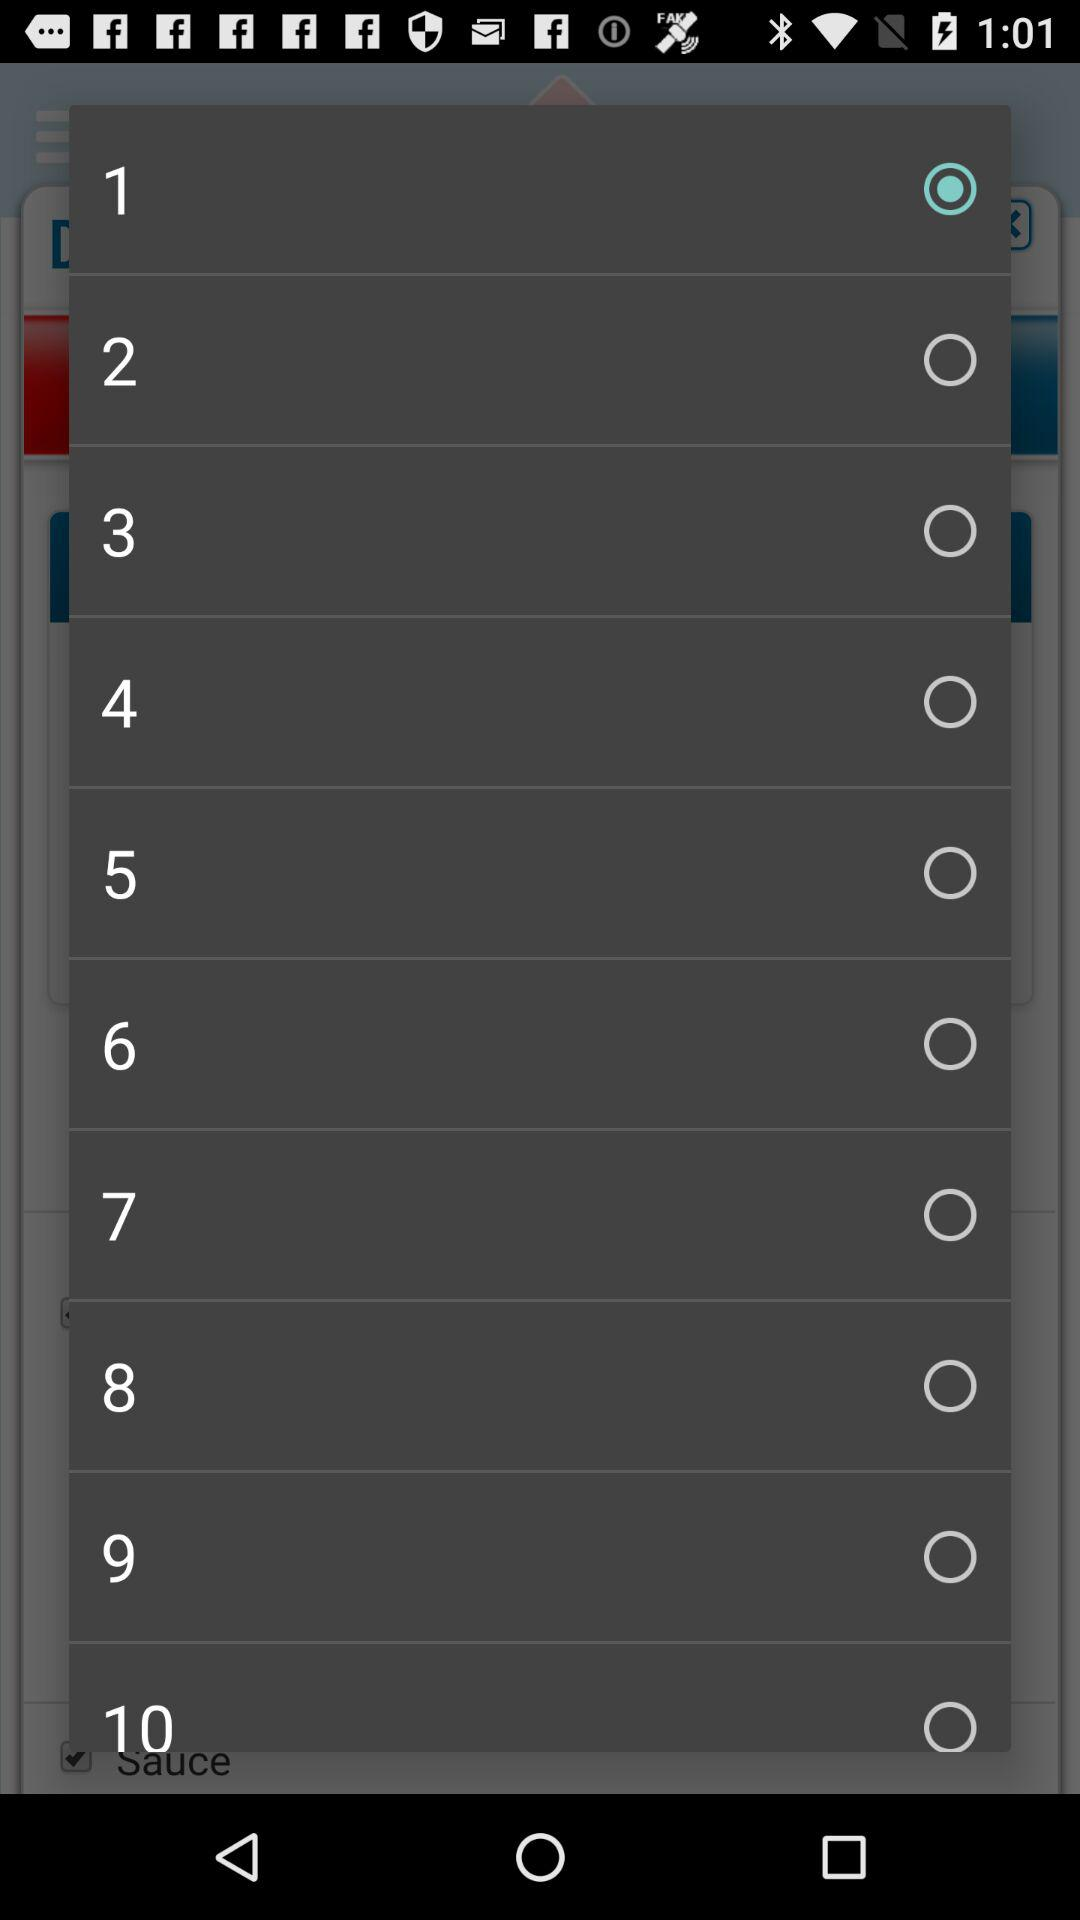How many options are available in total?
When the provided information is insufficient, respond with <no answer>. <no answer> 